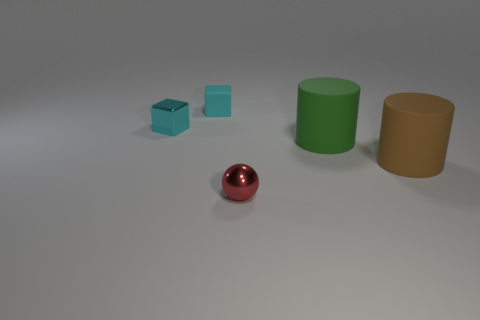What material is the tiny sphere?
Your answer should be compact. Metal. What is the object that is in front of the large brown rubber thing made of?
Your answer should be compact. Metal. Are there any other things of the same color as the matte block?
Your answer should be compact. Yes. There is a brown cylinder that is made of the same material as the big green cylinder; what is its size?
Provide a short and direct response. Large. What number of large things are blue shiny spheres or brown things?
Keep it short and to the point. 1. How big is the thing on the left side of the block behind the small shiny object behind the ball?
Provide a succinct answer. Small. What number of brown cylinders have the same size as the red thing?
Make the answer very short. 0. How many things are metal cylinders or large things that are behind the large brown rubber thing?
Make the answer very short. 1. What is the shape of the cyan matte object?
Keep it short and to the point. Cube. Is the small ball the same color as the small matte thing?
Your answer should be very brief. No. 